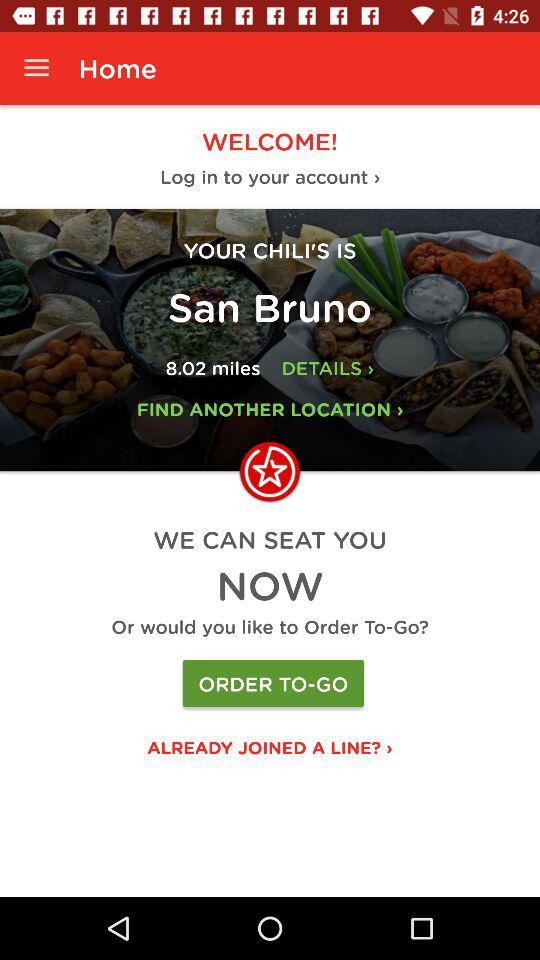How many miles away is the nearest Chili's?
Answer the question using a single word or phrase. 8.02 